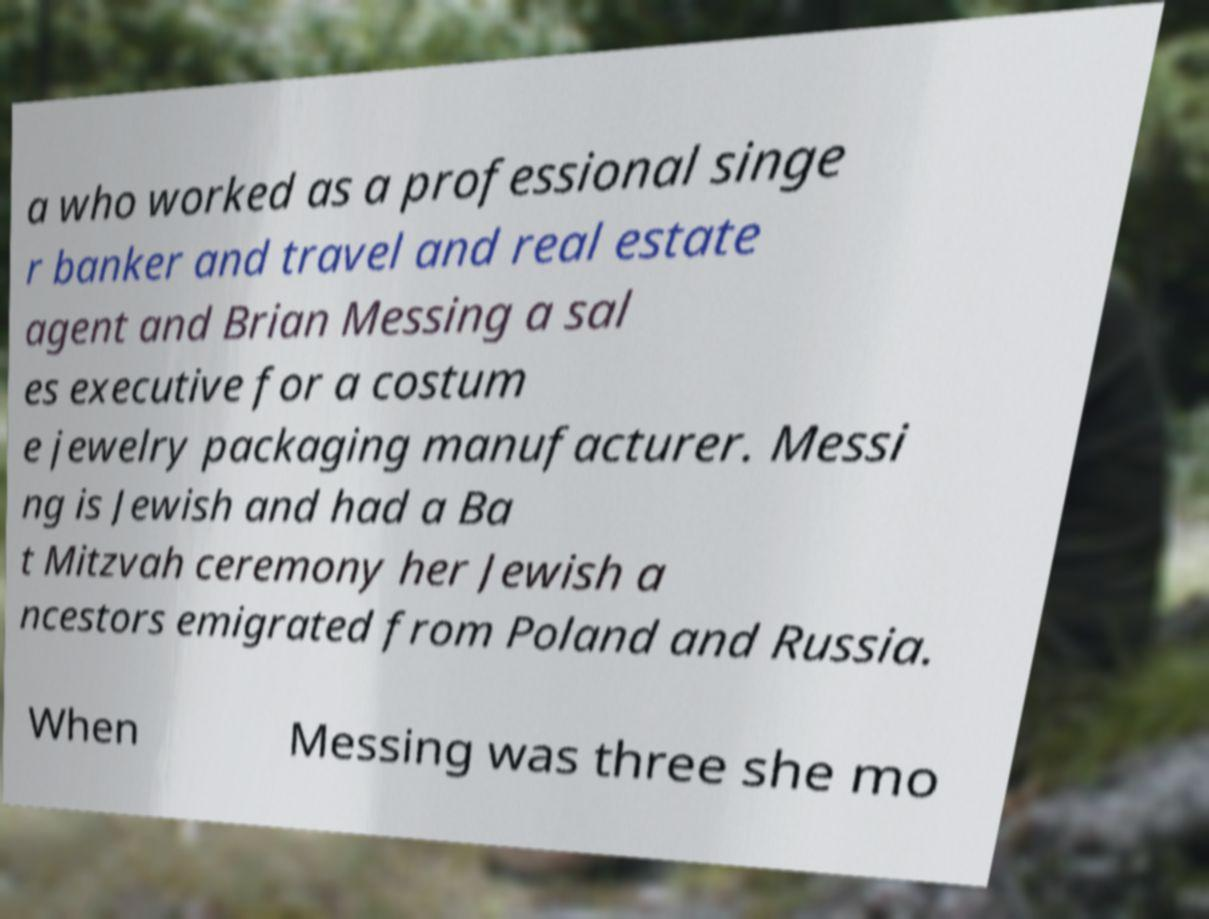What messages or text are displayed in this image? I need them in a readable, typed format. a who worked as a professional singe r banker and travel and real estate agent and Brian Messing a sal es executive for a costum e jewelry packaging manufacturer. Messi ng is Jewish and had a Ba t Mitzvah ceremony her Jewish a ncestors emigrated from Poland and Russia. When Messing was three she mo 